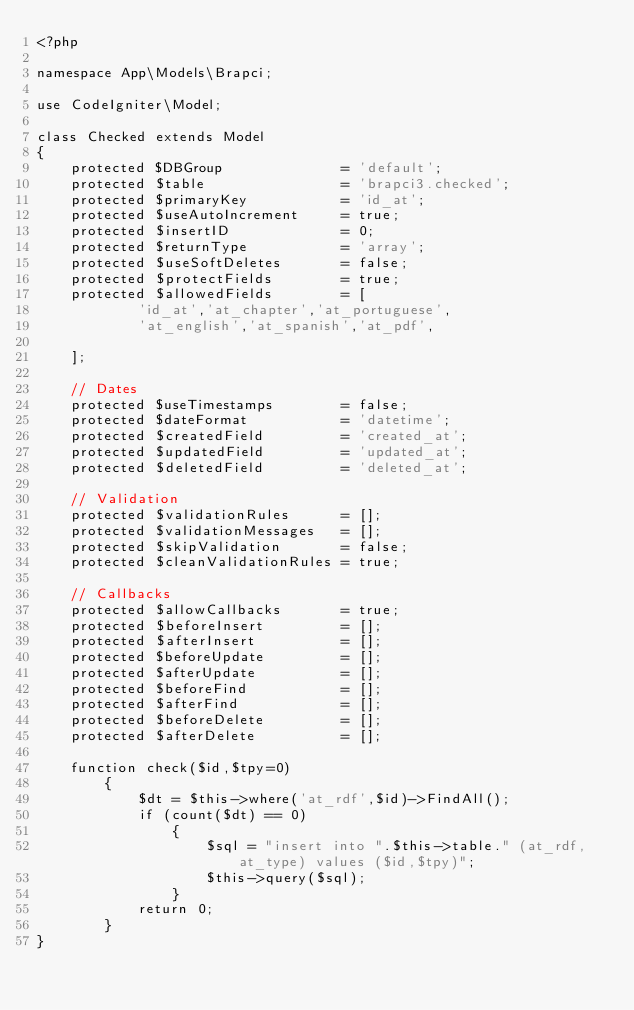<code> <loc_0><loc_0><loc_500><loc_500><_PHP_><?php

namespace App\Models\Brapci;

use CodeIgniter\Model;

class Checked extends Model
{
	protected $DBGroup              = 'default';
	protected $table                = 'brapci3.checked';
	protected $primaryKey           = 'id_at';
	protected $useAutoIncrement     = true;
	protected $insertID             = 0;
	protected $returnType           = 'array';
	protected $useSoftDeletes       = false;
	protected $protectFields        = true;
	protected $allowedFields        = [
			'id_at','at_chapter','at_portuguese',
			'at_english','at_spanish','at_pdf',

	];

	// Dates
	protected $useTimestamps        = false;
	protected $dateFormat           = 'datetime';
	protected $createdField         = 'created_at';
	protected $updatedField         = 'updated_at';
	protected $deletedField         = 'deleted_at';

	// Validation
	protected $validationRules      = [];
	protected $validationMessages   = [];
	protected $skipValidation       = false;
	protected $cleanValidationRules = true;

	// Callbacks
	protected $allowCallbacks       = true;
	protected $beforeInsert         = [];
	protected $afterInsert          = [];
	protected $beforeUpdate         = [];
	protected $afterUpdate          = [];
	protected $beforeFind           = [];
	protected $afterFind            = [];
	protected $beforeDelete         = [];
	protected $afterDelete          = [];

	function check($id,$tpy=0)
		{
			$dt = $this->where('at_rdf',$id)->FindAll();
			if (count($dt) == 0)
				{
					$sql = "insert into ".$this->table." (at_rdf,at_type) values ($id,$tpy)";
					$this->query($sql);
				}
			return 0;
		}
}
</code> 